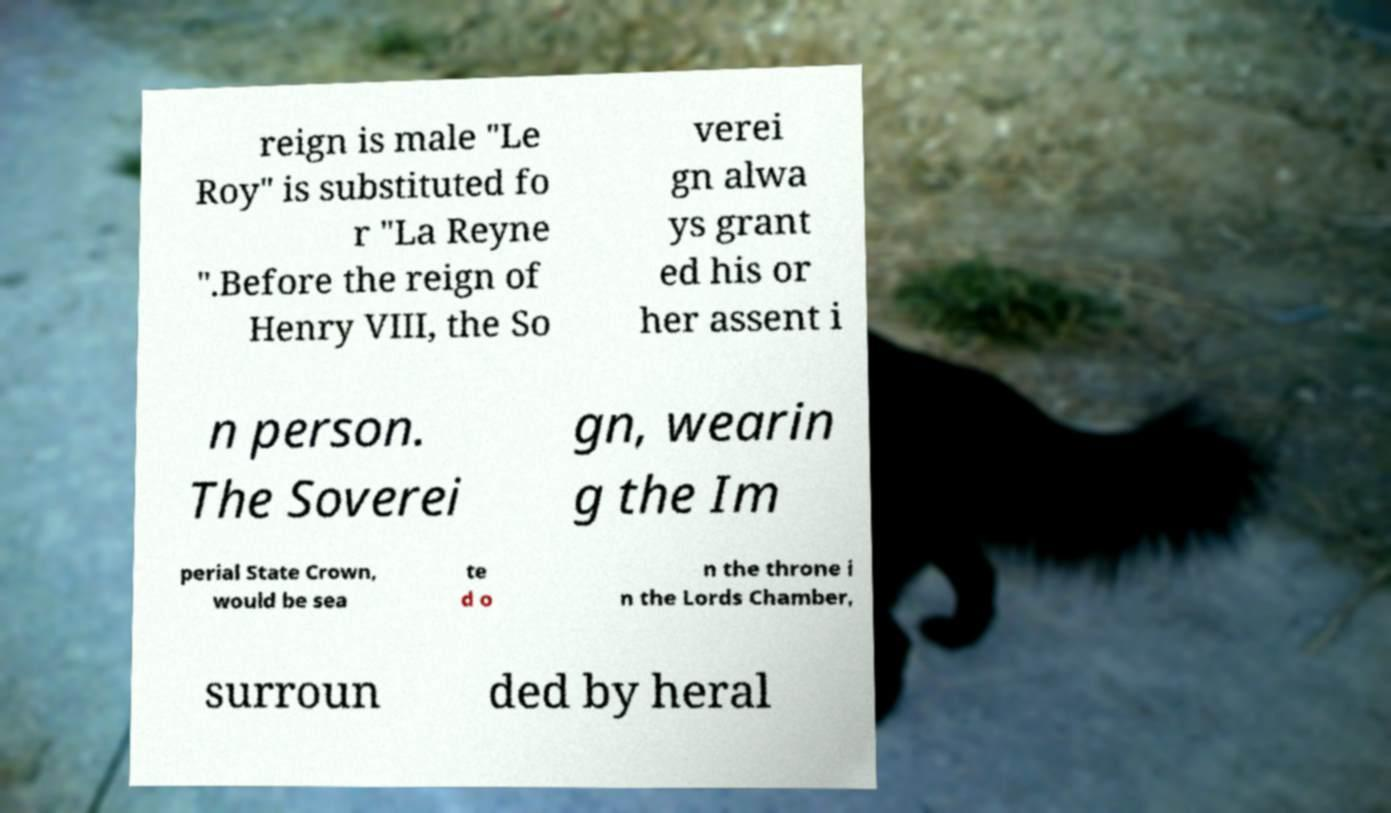There's text embedded in this image that I need extracted. Can you transcribe it verbatim? reign is male "Le Roy" is substituted fo r "La Reyne ".Before the reign of Henry VIII, the So verei gn alwa ys grant ed his or her assent i n person. The Soverei gn, wearin g the Im perial State Crown, would be sea te d o n the throne i n the Lords Chamber, surroun ded by heral 